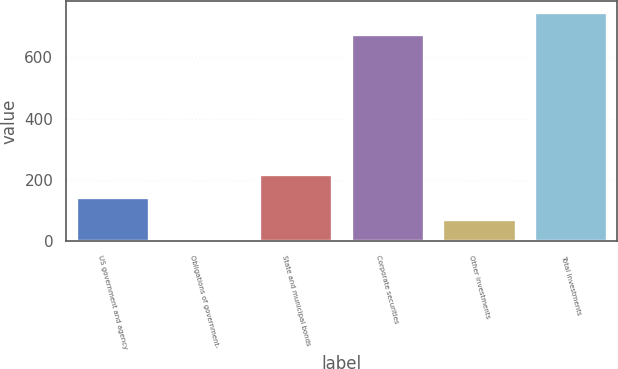<chart> <loc_0><loc_0><loc_500><loc_500><bar_chart><fcel>US government and agency<fcel>Obligations of government-<fcel>State and municipal bonds<fcel>Corporate securities<fcel>Other investments<fcel>Total investments<nl><fcel>145.4<fcel>1<fcel>217.6<fcel>675<fcel>73.2<fcel>747.2<nl></chart> 